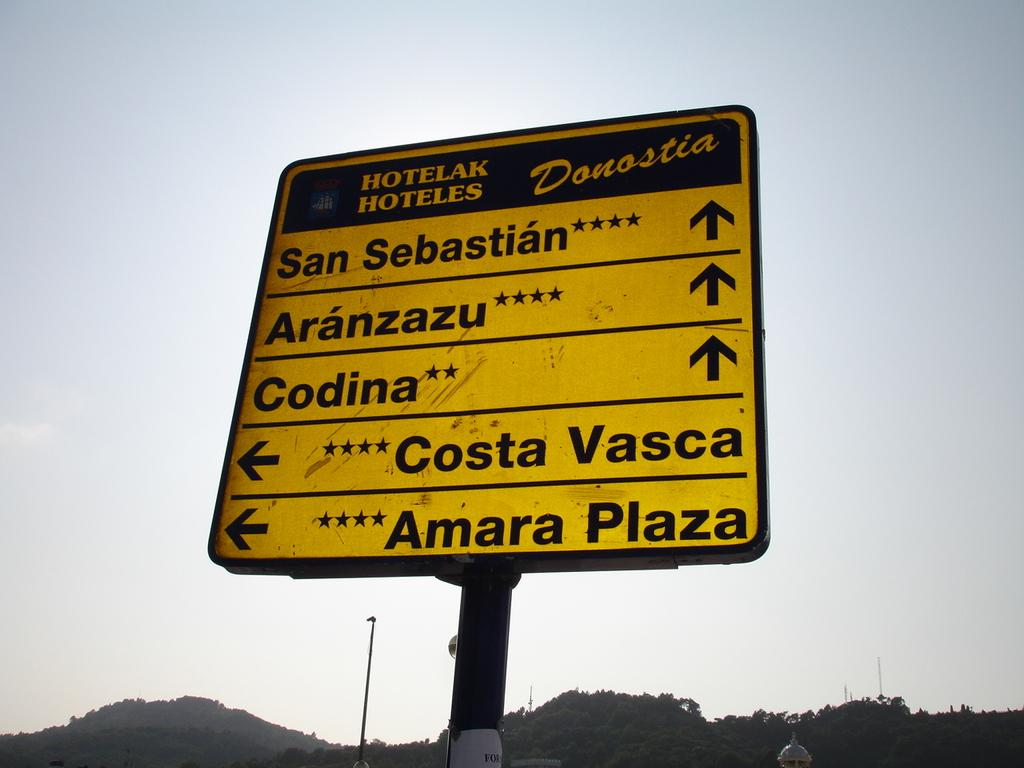<image>
Render a clear and concise summary of the photo. A sign has an arrow pointing to the left with the name Costa Vasca on it. 